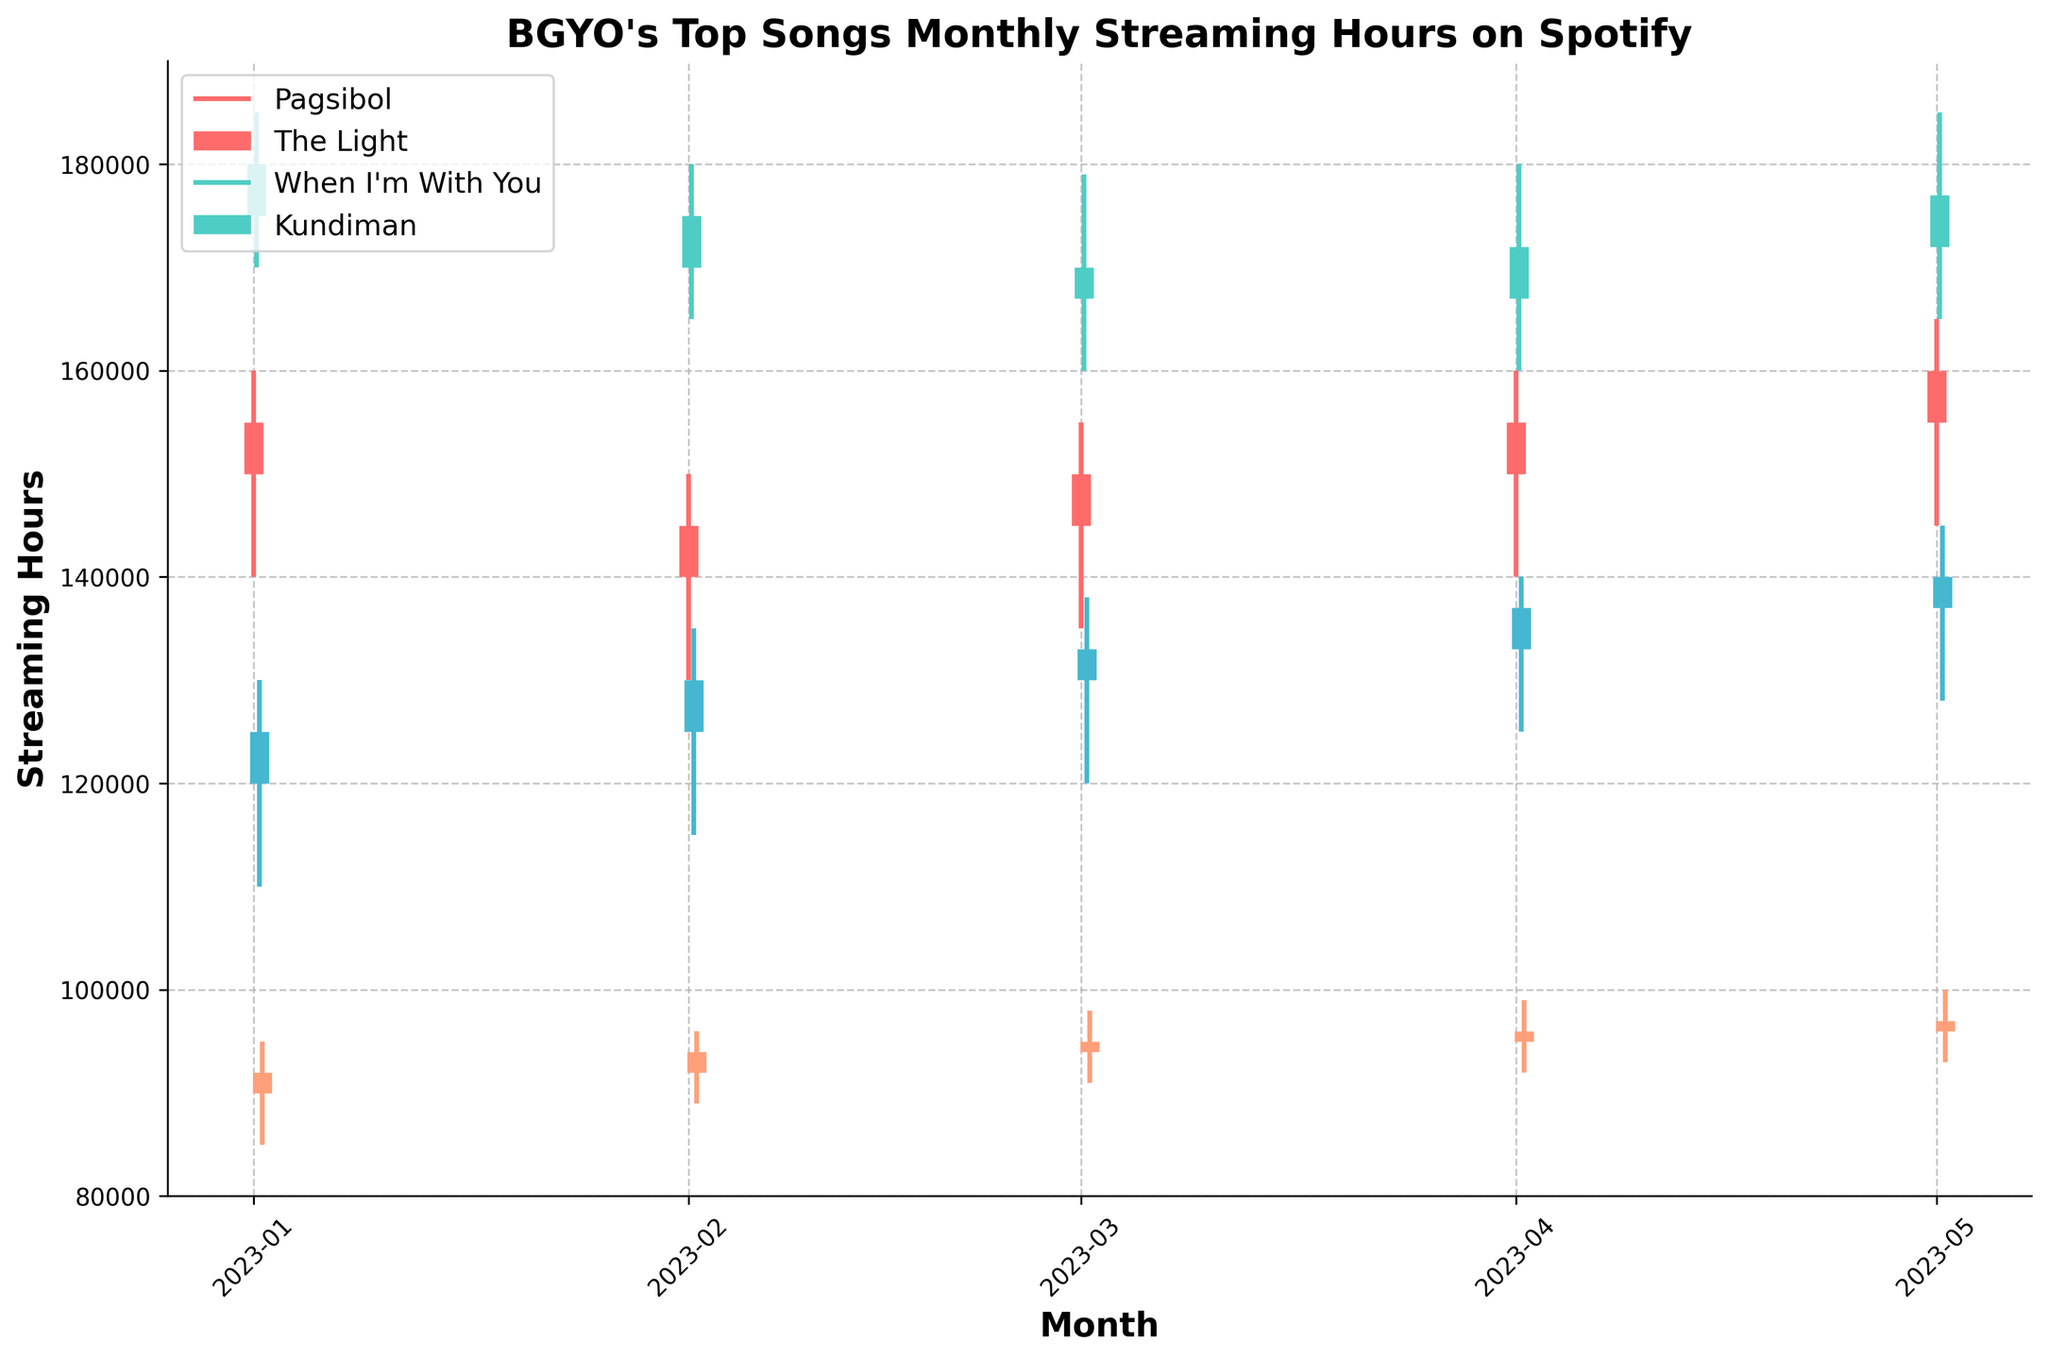What is the title of the plot? The main heading of the plot, usually at the top of the chart, provides a summary of what the chart is about. In this case, it is centered and bolded.
Answer: "BGYO's Top Songs Monthly Streaming Hours on Spotify" How many tracks are displayed in the plot? Each unique track represented in the plot is identified by different colored lines/bars and labeled in the legend. Count the distinct labels in the legend.
Answer: 4 What month had the highest streaming hours for "Pagsibol"? Identify the month by comparing the highest points reached by the vertical lines labeled for "Pagsibol" in the plot. The specific month corresponds to the column 'High'.
Answer: January 2023 Which track had the highest closing streaming hours in May 2023? Look for the vertical bar that ends at the highest point in May 2023. The 'Close' point at the top of the bar indicates the closing streaming hours for that month.
Answer: "The Light" Did the streaming hours for "When I'm With You" increase or decrease in April 2023 compared to March 2023? Compare the 'Close' points (end of bars) for "When I'm With You" between March and April 2023. Increased if April's 'Close' is higher, decreased if lower.
Answer: Increased What is the average high streaming hours for "Kundiman" across the displayed months? Add up all the 'High' values for "Kundiman" and divide by the number of months. These values are vertical line peaks. So, (95000+96000+98000+99000+100000)/5 = 482000/5 = 96400.
Answer: 96400 Which track shows the most variability in streaming hours in a single month and which month? Variability in a candlestick plot is shown by the difference between the 'High' and 'Low' points. Compare the (High - Low) differences for each track and month to find the largest. For example, Pagsibol in January is (160000 - 140000 = 20000).
Answer: "The Light" in January 2023 For "Pagsibol," were the closing streaming hours higher or lower than the opening streaming hours in February 2023? Check the 'Open' and 'Close' points for "Pagsibol" in February 2023. 'Close' above 'Open' indicates higher, and below indicates lower.
Answer: Lower What is the median value of the closing streaming hours for "The Light" over the displayed months? List the 'Close' values for "The Light" in order (175000, 170000, 167000, 172000, 177000) and find the middle value. In this set, the middle value (when ordered) is 172000.
Answer: 172000 Which month showed the overall highest streaming hours among all tracks? Identify the maximum 'High' value among all tracks and months, and then determine the corresponding month to that maximum value.
Answer: May 2023 